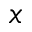<formula> <loc_0><loc_0><loc_500><loc_500>x</formula> 